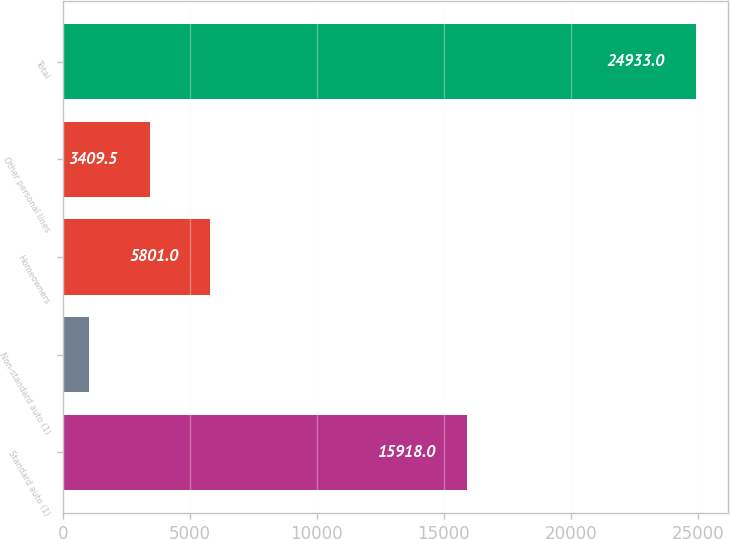Convert chart. <chart><loc_0><loc_0><loc_500><loc_500><bar_chart><fcel>Standard auto (1)<fcel>Non-standard auto (1)<fcel>Homeowners<fcel>Other personal lines<fcel>Total<nl><fcel>15918<fcel>1018<fcel>5801<fcel>3409.5<fcel>24933<nl></chart> 